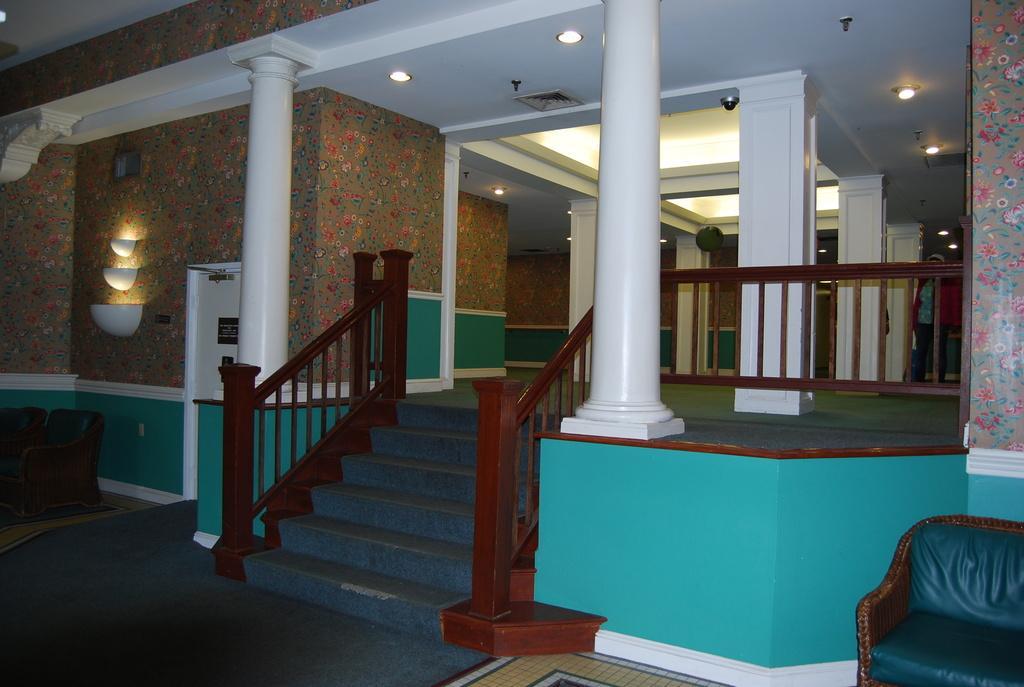In one or two sentences, can you explain what this image depicts? This is a building. In the middle of this image I can see the stairs and white color pillars. On the top of the image I can see the lights are attached to the top. On the left side there is a couch. On the right side, I can see a chair on the floor. In the background I can see a person is walking on the floor. 